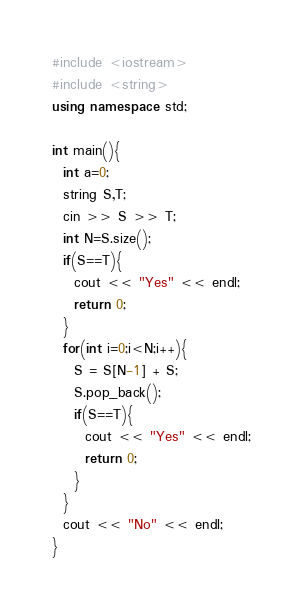<code> <loc_0><loc_0><loc_500><loc_500><_C++_>#include <iostream>
#include <string>
using namespace std;

int main(){
  int a=0;
  string S,T;
  cin >> S >> T;
  int N=S.size();
  if(S==T){
    cout << "Yes" << endl;
    return 0;
  }
  for(int i=0;i<N;i++){
    S = S[N-1] + S;
    S.pop_back();
    if(S==T){
      cout << "Yes" << endl;
      return 0;
    }
  }
  cout << "No" << endl;
}
</code> 